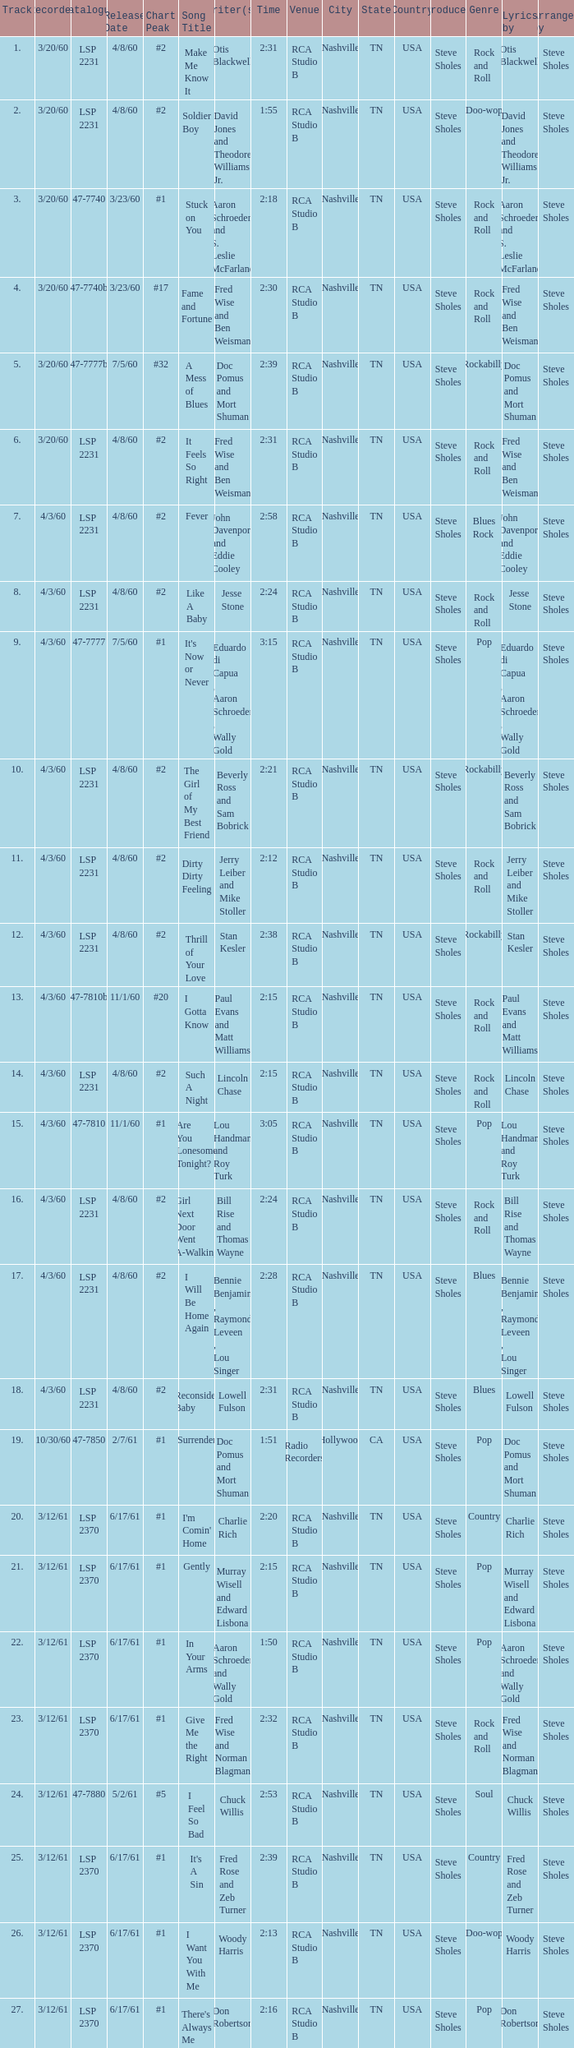On songs with track numbers smaller than number 17 and catalogues of LSP 2231, who are the writer(s)? Otis Blackwell, David Jones and Theodore Williams Jr., Fred Wise and Ben Weisman, John Davenport and Eddie Cooley, Jesse Stone, Beverly Ross and Sam Bobrick, Jerry Leiber and Mike Stoller, Stan Kesler, Lincoln Chase, Bill Rise and Thomas Wayne. 